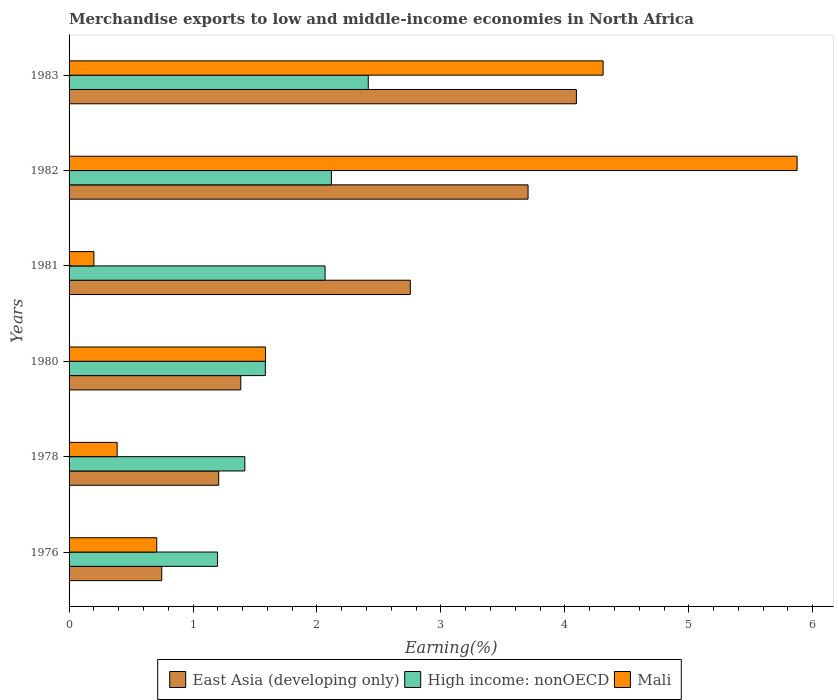Are the number of bars per tick equal to the number of legend labels?
Keep it short and to the point. Yes. How many bars are there on the 1st tick from the bottom?
Your answer should be very brief. 3. What is the percentage of amount earned from merchandise exports in East Asia (developing only) in 1980?
Give a very brief answer. 1.39. Across all years, what is the maximum percentage of amount earned from merchandise exports in High income: nonOECD?
Offer a very short reply. 2.41. Across all years, what is the minimum percentage of amount earned from merchandise exports in Mali?
Your answer should be very brief. 0.2. In which year was the percentage of amount earned from merchandise exports in East Asia (developing only) minimum?
Your answer should be compact. 1976. What is the total percentage of amount earned from merchandise exports in Mali in the graph?
Keep it short and to the point. 13.06. What is the difference between the percentage of amount earned from merchandise exports in Mali in 1982 and that in 1983?
Keep it short and to the point. 1.56. What is the difference between the percentage of amount earned from merchandise exports in High income: nonOECD in 1983 and the percentage of amount earned from merchandise exports in East Asia (developing only) in 1976?
Your response must be concise. 1.67. What is the average percentage of amount earned from merchandise exports in East Asia (developing only) per year?
Your answer should be very brief. 2.31. In the year 1983, what is the difference between the percentage of amount earned from merchandise exports in East Asia (developing only) and percentage of amount earned from merchandise exports in High income: nonOECD?
Your answer should be compact. 1.68. What is the ratio of the percentage of amount earned from merchandise exports in Mali in 1978 to that in 1983?
Make the answer very short. 0.09. Is the percentage of amount earned from merchandise exports in East Asia (developing only) in 1980 less than that in 1983?
Your response must be concise. Yes. What is the difference between the highest and the second highest percentage of amount earned from merchandise exports in Mali?
Make the answer very short. 1.56. What is the difference between the highest and the lowest percentage of amount earned from merchandise exports in Mali?
Your response must be concise. 5.67. In how many years, is the percentage of amount earned from merchandise exports in East Asia (developing only) greater than the average percentage of amount earned from merchandise exports in East Asia (developing only) taken over all years?
Keep it short and to the point. 3. What does the 3rd bar from the top in 1978 represents?
Offer a terse response. East Asia (developing only). What does the 1st bar from the bottom in 1978 represents?
Ensure brevity in your answer.  East Asia (developing only). How many bars are there?
Give a very brief answer. 18. Are all the bars in the graph horizontal?
Keep it short and to the point. Yes. Are the values on the major ticks of X-axis written in scientific E-notation?
Ensure brevity in your answer.  No. Does the graph contain grids?
Provide a succinct answer. No. Where does the legend appear in the graph?
Offer a very short reply. Bottom center. How many legend labels are there?
Keep it short and to the point. 3. How are the legend labels stacked?
Provide a short and direct response. Horizontal. What is the title of the graph?
Your answer should be very brief. Merchandise exports to low and middle-income economies in North Africa. What is the label or title of the X-axis?
Offer a very short reply. Earning(%). What is the Earning(%) in East Asia (developing only) in 1976?
Ensure brevity in your answer.  0.75. What is the Earning(%) of High income: nonOECD in 1976?
Offer a very short reply. 1.2. What is the Earning(%) in Mali in 1976?
Make the answer very short. 0.71. What is the Earning(%) of East Asia (developing only) in 1978?
Make the answer very short. 1.21. What is the Earning(%) of High income: nonOECD in 1978?
Provide a short and direct response. 1.42. What is the Earning(%) of Mali in 1978?
Provide a short and direct response. 0.39. What is the Earning(%) in East Asia (developing only) in 1980?
Give a very brief answer. 1.39. What is the Earning(%) in High income: nonOECD in 1980?
Your answer should be compact. 1.58. What is the Earning(%) in Mali in 1980?
Provide a short and direct response. 1.59. What is the Earning(%) in East Asia (developing only) in 1981?
Your answer should be compact. 2.75. What is the Earning(%) in High income: nonOECD in 1981?
Your response must be concise. 2.07. What is the Earning(%) in Mali in 1981?
Offer a terse response. 0.2. What is the Earning(%) of East Asia (developing only) in 1982?
Give a very brief answer. 3.7. What is the Earning(%) in High income: nonOECD in 1982?
Provide a short and direct response. 2.12. What is the Earning(%) in Mali in 1982?
Offer a terse response. 5.87. What is the Earning(%) in East Asia (developing only) in 1983?
Provide a short and direct response. 4.09. What is the Earning(%) of High income: nonOECD in 1983?
Give a very brief answer. 2.41. What is the Earning(%) in Mali in 1983?
Offer a very short reply. 4.31. Across all years, what is the maximum Earning(%) in East Asia (developing only)?
Your answer should be very brief. 4.09. Across all years, what is the maximum Earning(%) of High income: nonOECD?
Your answer should be compact. 2.41. Across all years, what is the maximum Earning(%) of Mali?
Give a very brief answer. 5.87. Across all years, what is the minimum Earning(%) in East Asia (developing only)?
Offer a very short reply. 0.75. Across all years, what is the minimum Earning(%) in High income: nonOECD?
Offer a terse response. 1.2. Across all years, what is the minimum Earning(%) in Mali?
Keep it short and to the point. 0.2. What is the total Earning(%) in East Asia (developing only) in the graph?
Your answer should be very brief. 13.89. What is the total Earning(%) of High income: nonOECD in the graph?
Offer a terse response. 10.79. What is the total Earning(%) of Mali in the graph?
Keep it short and to the point. 13.06. What is the difference between the Earning(%) in East Asia (developing only) in 1976 and that in 1978?
Ensure brevity in your answer.  -0.46. What is the difference between the Earning(%) in High income: nonOECD in 1976 and that in 1978?
Ensure brevity in your answer.  -0.22. What is the difference between the Earning(%) in Mali in 1976 and that in 1978?
Provide a succinct answer. 0.32. What is the difference between the Earning(%) in East Asia (developing only) in 1976 and that in 1980?
Offer a terse response. -0.64. What is the difference between the Earning(%) of High income: nonOECD in 1976 and that in 1980?
Your answer should be compact. -0.39. What is the difference between the Earning(%) in Mali in 1976 and that in 1980?
Ensure brevity in your answer.  -0.88. What is the difference between the Earning(%) in East Asia (developing only) in 1976 and that in 1981?
Keep it short and to the point. -2.01. What is the difference between the Earning(%) of High income: nonOECD in 1976 and that in 1981?
Your response must be concise. -0.87. What is the difference between the Earning(%) of Mali in 1976 and that in 1981?
Provide a succinct answer. 0.51. What is the difference between the Earning(%) in East Asia (developing only) in 1976 and that in 1982?
Give a very brief answer. -2.96. What is the difference between the Earning(%) in High income: nonOECD in 1976 and that in 1982?
Offer a very short reply. -0.92. What is the difference between the Earning(%) of Mali in 1976 and that in 1982?
Your answer should be compact. -5.17. What is the difference between the Earning(%) of East Asia (developing only) in 1976 and that in 1983?
Give a very brief answer. -3.35. What is the difference between the Earning(%) in High income: nonOECD in 1976 and that in 1983?
Provide a short and direct response. -1.22. What is the difference between the Earning(%) in Mali in 1976 and that in 1983?
Offer a terse response. -3.6. What is the difference between the Earning(%) of East Asia (developing only) in 1978 and that in 1980?
Make the answer very short. -0.18. What is the difference between the Earning(%) in High income: nonOECD in 1978 and that in 1980?
Ensure brevity in your answer.  -0.17. What is the difference between the Earning(%) of Mali in 1978 and that in 1980?
Ensure brevity in your answer.  -1.2. What is the difference between the Earning(%) of East Asia (developing only) in 1978 and that in 1981?
Your answer should be compact. -1.55. What is the difference between the Earning(%) in High income: nonOECD in 1978 and that in 1981?
Make the answer very short. -0.65. What is the difference between the Earning(%) in Mali in 1978 and that in 1981?
Make the answer very short. 0.19. What is the difference between the Earning(%) of East Asia (developing only) in 1978 and that in 1982?
Keep it short and to the point. -2.5. What is the difference between the Earning(%) in High income: nonOECD in 1978 and that in 1982?
Your response must be concise. -0.7. What is the difference between the Earning(%) of Mali in 1978 and that in 1982?
Your answer should be very brief. -5.49. What is the difference between the Earning(%) in East Asia (developing only) in 1978 and that in 1983?
Give a very brief answer. -2.89. What is the difference between the Earning(%) of High income: nonOECD in 1978 and that in 1983?
Keep it short and to the point. -1. What is the difference between the Earning(%) in Mali in 1978 and that in 1983?
Make the answer very short. -3.92. What is the difference between the Earning(%) of East Asia (developing only) in 1980 and that in 1981?
Your response must be concise. -1.37. What is the difference between the Earning(%) of High income: nonOECD in 1980 and that in 1981?
Your response must be concise. -0.48. What is the difference between the Earning(%) in Mali in 1980 and that in 1981?
Give a very brief answer. 1.38. What is the difference between the Earning(%) in East Asia (developing only) in 1980 and that in 1982?
Keep it short and to the point. -2.32. What is the difference between the Earning(%) of High income: nonOECD in 1980 and that in 1982?
Your answer should be very brief. -0.53. What is the difference between the Earning(%) of Mali in 1980 and that in 1982?
Provide a short and direct response. -4.29. What is the difference between the Earning(%) in East Asia (developing only) in 1980 and that in 1983?
Your answer should be very brief. -2.71. What is the difference between the Earning(%) in High income: nonOECD in 1980 and that in 1983?
Keep it short and to the point. -0.83. What is the difference between the Earning(%) in Mali in 1980 and that in 1983?
Provide a succinct answer. -2.72. What is the difference between the Earning(%) of East Asia (developing only) in 1981 and that in 1982?
Provide a short and direct response. -0.95. What is the difference between the Earning(%) of High income: nonOECD in 1981 and that in 1982?
Provide a succinct answer. -0.05. What is the difference between the Earning(%) of Mali in 1981 and that in 1982?
Your response must be concise. -5.67. What is the difference between the Earning(%) in East Asia (developing only) in 1981 and that in 1983?
Your answer should be very brief. -1.34. What is the difference between the Earning(%) of High income: nonOECD in 1981 and that in 1983?
Offer a terse response. -0.35. What is the difference between the Earning(%) of Mali in 1981 and that in 1983?
Your response must be concise. -4.11. What is the difference between the Earning(%) of East Asia (developing only) in 1982 and that in 1983?
Your response must be concise. -0.39. What is the difference between the Earning(%) of High income: nonOECD in 1982 and that in 1983?
Your answer should be compact. -0.3. What is the difference between the Earning(%) of Mali in 1982 and that in 1983?
Your answer should be very brief. 1.56. What is the difference between the Earning(%) in East Asia (developing only) in 1976 and the Earning(%) in High income: nonOECD in 1978?
Ensure brevity in your answer.  -0.67. What is the difference between the Earning(%) in East Asia (developing only) in 1976 and the Earning(%) in Mali in 1978?
Your answer should be compact. 0.36. What is the difference between the Earning(%) in High income: nonOECD in 1976 and the Earning(%) in Mali in 1978?
Give a very brief answer. 0.81. What is the difference between the Earning(%) in East Asia (developing only) in 1976 and the Earning(%) in High income: nonOECD in 1980?
Your answer should be very brief. -0.84. What is the difference between the Earning(%) of East Asia (developing only) in 1976 and the Earning(%) of Mali in 1980?
Your answer should be compact. -0.84. What is the difference between the Earning(%) of High income: nonOECD in 1976 and the Earning(%) of Mali in 1980?
Your answer should be very brief. -0.39. What is the difference between the Earning(%) in East Asia (developing only) in 1976 and the Earning(%) in High income: nonOECD in 1981?
Offer a very short reply. -1.32. What is the difference between the Earning(%) of East Asia (developing only) in 1976 and the Earning(%) of Mali in 1981?
Your response must be concise. 0.55. What is the difference between the Earning(%) in High income: nonOECD in 1976 and the Earning(%) in Mali in 1981?
Make the answer very short. 1. What is the difference between the Earning(%) of East Asia (developing only) in 1976 and the Earning(%) of High income: nonOECD in 1982?
Provide a succinct answer. -1.37. What is the difference between the Earning(%) in East Asia (developing only) in 1976 and the Earning(%) in Mali in 1982?
Ensure brevity in your answer.  -5.13. What is the difference between the Earning(%) in High income: nonOECD in 1976 and the Earning(%) in Mali in 1982?
Ensure brevity in your answer.  -4.68. What is the difference between the Earning(%) in East Asia (developing only) in 1976 and the Earning(%) in High income: nonOECD in 1983?
Keep it short and to the point. -1.67. What is the difference between the Earning(%) in East Asia (developing only) in 1976 and the Earning(%) in Mali in 1983?
Ensure brevity in your answer.  -3.56. What is the difference between the Earning(%) of High income: nonOECD in 1976 and the Earning(%) of Mali in 1983?
Provide a succinct answer. -3.11. What is the difference between the Earning(%) in East Asia (developing only) in 1978 and the Earning(%) in High income: nonOECD in 1980?
Ensure brevity in your answer.  -0.38. What is the difference between the Earning(%) of East Asia (developing only) in 1978 and the Earning(%) of Mali in 1980?
Offer a very short reply. -0.38. What is the difference between the Earning(%) of High income: nonOECD in 1978 and the Earning(%) of Mali in 1980?
Offer a very short reply. -0.17. What is the difference between the Earning(%) of East Asia (developing only) in 1978 and the Earning(%) of High income: nonOECD in 1981?
Your response must be concise. -0.86. What is the difference between the Earning(%) in East Asia (developing only) in 1978 and the Earning(%) in Mali in 1981?
Your response must be concise. 1.01. What is the difference between the Earning(%) of High income: nonOECD in 1978 and the Earning(%) of Mali in 1981?
Keep it short and to the point. 1.22. What is the difference between the Earning(%) of East Asia (developing only) in 1978 and the Earning(%) of High income: nonOECD in 1982?
Your answer should be compact. -0.91. What is the difference between the Earning(%) in East Asia (developing only) in 1978 and the Earning(%) in Mali in 1982?
Provide a succinct answer. -4.67. What is the difference between the Earning(%) of High income: nonOECD in 1978 and the Earning(%) of Mali in 1982?
Offer a terse response. -4.46. What is the difference between the Earning(%) of East Asia (developing only) in 1978 and the Earning(%) of High income: nonOECD in 1983?
Offer a terse response. -1.21. What is the difference between the Earning(%) of East Asia (developing only) in 1978 and the Earning(%) of Mali in 1983?
Ensure brevity in your answer.  -3.1. What is the difference between the Earning(%) in High income: nonOECD in 1978 and the Earning(%) in Mali in 1983?
Offer a very short reply. -2.89. What is the difference between the Earning(%) in East Asia (developing only) in 1980 and the Earning(%) in High income: nonOECD in 1981?
Offer a very short reply. -0.68. What is the difference between the Earning(%) in East Asia (developing only) in 1980 and the Earning(%) in Mali in 1981?
Offer a very short reply. 1.18. What is the difference between the Earning(%) of High income: nonOECD in 1980 and the Earning(%) of Mali in 1981?
Make the answer very short. 1.38. What is the difference between the Earning(%) of East Asia (developing only) in 1980 and the Earning(%) of High income: nonOECD in 1982?
Offer a terse response. -0.73. What is the difference between the Earning(%) of East Asia (developing only) in 1980 and the Earning(%) of Mali in 1982?
Ensure brevity in your answer.  -4.49. What is the difference between the Earning(%) of High income: nonOECD in 1980 and the Earning(%) of Mali in 1982?
Keep it short and to the point. -4.29. What is the difference between the Earning(%) in East Asia (developing only) in 1980 and the Earning(%) in High income: nonOECD in 1983?
Give a very brief answer. -1.03. What is the difference between the Earning(%) of East Asia (developing only) in 1980 and the Earning(%) of Mali in 1983?
Offer a very short reply. -2.92. What is the difference between the Earning(%) in High income: nonOECD in 1980 and the Earning(%) in Mali in 1983?
Offer a terse response. -2.73. What is the difference between the Earning(%) of East Asia (developing only) in 1981 and the Earning(%) of High income: nonOECD in 1982?
Make the answer very short. 0.64. What is the difference between the Earning(%) in East Asia (developing only) in 1981 and the Earning(%) in Mali in 1982?
Give a very brief answer. -3.12. What is the difference between the Earning(%) in High income: nonOECD in 1981 and the Earning(%) in Mali in 1982?
Provide a short and direct response. -3.81. What is the difference between the Earning(%) in East Asia (developing only) in 1981 and the Earning(%) in High income: nonOECD in 1983?
Offer a terse response. 0.34. What is the difference between the Earning(%) in East Asia (developing only) in 1981 and the Earning(%) in Mali in 1983?
Your answer should be very brief. -1.56. What is the difference between the Earning(%) in High income: nonOECD in 1981 and the Earning(%) in Mali in 1983?
Your answer should be compact. -2.24. What is the difference between the Earning(%) in East Asia (developing only) in 1982 and the Earning(%) in High income: nonOECD in 1983?
Provide a succinct answer. 1.29. What is the difference between the Earning(%) in East Asia (developing only) in 1982 and the Earning(%) in Mali in 1983?
Ensure brevity in your answer.  -0.61. What is the difference between the Earning(%) of High income: nonOECD in 1982 and the Earning(%) of Mali in 1983?
Provide a short and direct response. -2.19. What is the average Earning(%) in East Asia (developing only) per year?
Your response must be concise. 2.31. What is the average Earning(%) of High income: nonOECD per year?
Provide a short and direct response. 1.8. What is the average Earning(%) of Mali per year?
Your answer should be very brief. 2.18. In the year 1976, what is the difference between the Earning(%) in East Asia (developing only) and Earning(%) in High income: nonOECD?
Your answer should be very brief. -0.45. In the year 1976, what is the difference between the Earning(%) in East Asia (developing only) and Earning(%) in Mali?
Your response must be concise. 0.04. In the year 1976, what is the difference between the Earning(%) in High income: nonOECD and Earning(%) in Mali?
Your response must be concise. 0.49. In the year 1978, what is the difference between the Earning(%) in East Asia (developing only) and Earning(%) in High income: nonOECD?
Offer a very short reply. -0.21. In the year 1978, what is the difference between the Earning(%) of East Asia (developing only) and Earning(%) of Mali?
Make the answer very short. 0.82. In the year 1978, what is the difference between the Earning(%) in High income: nonOECD and Earning(%) in Mali?
Ensure brevity in your answer.  1.03. In the year 1980, what is the difference between the Earning(%) of East Asia (developing only) and Earning(%) of High income: nonOECD?
Give a very brief answer. -0.2. In the year 1980, what is the difference between the Earning(%) of East Asia (developing only) and Earning(%) of Mali?
Your response must be concise. -0.2. In the year 1980, what is the difference between the Earning(%) of High income: nonOECD and Earning(%) of Mali?
Give a very brief answer. -0. In the year 1981, what is the difference between the Earning(%) of East Asia (developing only) and Earning(%) of High income: nonOECD?
Provide a short and direct response. 0.69. In the year 1981, what is the difference between the Earning(%) of East Asia (developing only) and Earning(%) of Mali?
Offer a very short reply. 2.55. In the year 1981, what is the difference between the Earning(%) in High income: nonOECD and Earning(%) in Mali?
Your answer should be compact. 1.86. In the year 1982, what is the difference between the Earning(%) of East Asia (developing only) and Earning(%) of High income: nonOECD?
Make the answer very short. 1.59. In the year 1982, what is the difference between the Earning(%) in East Asia (developing only) and Earning(%) in Mali?
Your answer should be very brief. -2.17. In the year 1982, what is the difference between the Earning(%) in High income: nonOECD and Earning(%) in Mali?
Offer a terse response. -3.76. In the year 1983, what is the difference between the Earning(%) in East Asia (developing only) and Earning(%) in High income: nonOECD?
Make the answer very short. 1.68. In the year 1983, what is the difference between the Earning(%) in East Asia (developing only) and Earning(%) in Mali?
Provide a succinct answer. -0.22. In the year 1983, what is the difference between the Earning(%) of High income: nonOECD and Earning(%) of Mali?
Provide a succinct answer. -1.89. What is the ratio of the Earning(%) in East Asia (developing only) in 1976 to that in 1978?
Your answer should be very brief. 0.62. What is the ratio of the Earning(%) in High income: nonOECD in 1976 to that in 1978?
Offer a terse response. 0.84. What is the ratio of the Earning(%) in Mali in 1976 to that in 1978?
Make the answer very short. 1.82. What is the ratio of the Earning(%) of East Asia (developing only) in 1976 to that in 1980?
Your answer should be compact. 0.54. What is the ratio of the Earning(%) of High income: nonOECD in 1976 to that in 1980?
Ensure brevity in your answer.  0.76. What is the ratio of the Earning(%) in Mali in 1976 to that in 1980?
Offer a terse response. 0.45. What is the ratio of the Earning(%) in East Asia (developing only) in 1976 to that in 1981?
Make the answer very short. 0.27. What is the ratio of the Earning(%) in High income: nonOECD in 1976 to that in 1981?
Your answer should be very brief. 0.58. What is the ratio of the Earning(%) in Mali in 1976 to that in 1981?
Provide a short and direct response. 3.53. What is the ratio of the Earning(%) in East Asia (developing only) in 1976 to that in 1982?
Ensure brevity in your answer.  0.2. What is the ratio of the Earning(%) of High income: nonOECD in 1976 to that in 1982?
Ensure brevity in your answer.  0.57. What is the ratio of the Earning(%) in Mali in 1976 to that in 1982?
Your answer should be compact. 0.12. What is the ratio of the Earning(%) in East Asia (developing only) in 1976 to that in 1983?
Your answer should be very brief. 0.18. What is the ratio of the Earning(%) of High income: nonOECD in 1976 to that in 1983?
Keep it short and to the point. 0.5. What is the ratio of the Earning(%) of Mali in 1976 to that in 1983?
Offer a very short reply. 0.16. What is the ratio of the Earning(%) in East Asia (developing only) in 1978 to that in 1980?
Make the answer very short. 0.87. What is the ratio of the Earning(%) of High income: nonOECD in 1978 to that in 1980?
Your answer should be very brief. 0.9. What is the ratio of the Earning(%) of Mali in 1978 to that in 1980?
Your answer should be compact. 0.24. What is the ratio of the Earning(%) in East Asia (developing only) in 1978 to that in 1981?
Your answer should be compact. 0.44. What is the ratio of the Earning(%) of High income: nonOECD in 1978 to that in 1981?
Give a very brief answer. 0.69. What is the ratio of the Earning(%) of Mali in 1978 to that in 1981?
Your answer should be very brief. 1.93. What is the ratio of the Earning(%) of East Asia (developing only) in 1978 to that in 1982?
Ensure brevity in your answer.  0.33. What is the ratio of the Earning(%) of High income: nonOECD in 1978 to that in 1982?
Provide a short and direct response. 0.67. What is the ratio of the Earning(%) of Mali in 1978 to that in 1982?
Provide a succinct answer. 0.07. What is the ratio of the Earning(%) of East Asia (developing only) in 1978 to that in 1983?
Offer a terse response. 0.29. What is the ratio of the Earning(%) of High income: nonOECD in 1978 to that in 1983?
Make the answer very short. 0.59. What is the ratio of the Earning(%) of Mali in 1978 to that in 1983?
Provide a succinct answer. 0.09. What is the ratio of the Earning(%) in East Asia (developing only) in 1980 to that in 1981?
Keep it short and to the point. 0.5. What is the ratio of the Earning(%) of High income: nonOECD in 1980 to that in 1981?
Provide a succinct answer. 0.77. What is the ratio of the Earning(%) in Mali in 1980 to that in 1981?
Offer a terse response. 7.91. What is the ratio of the Earning(%) in East Asia (developing only) in 1980 to that in 1982?
Provide a short and direct response. 0.37. What is the ratio of the Earning(%) in High income: nonOECD in 1980 to that in 1982?
Give a very brief answer. 0.75. What is the ratio of the Earning(%) in Mali in 1980 to that in 1982?
Provide a short and direct response. 0.27. What is the ratio of the Earning(%) in East Asia (developing only) in 1980 to that in 1983?
Make the answer very short. 0.34. What is the ratio of the Earning(%) of High income: nonOECD in 1980 to that in 1983?
Keep it short and to the point. 0.66. What is the ratio of the Earning(%) in Mali in 1980 to that in 1983?
Offer a terse response. 0.37. What is the ratio of the Earning(%) of East Asia (developing only) in 1981 to that in 1982?
Offer a terse response. 0.74. What is the ratio of the Earning(%) of High income: nonOECD in 1981 to that in 1982?
Your answer should be very brief. 0.98. What is the ratio of the Earning(%) in Mali in 1981 to that in 1982?
Your answer should be compact. 0.03. What is the ratio of the Earning(%) in East Asia (developing only) in 1981 to that in 1983?
Offer a terse response. 0.67. What is the ratio of the Earning(%) of High income: nonOECD in 1981 to that in 1983?
Offer a very short reply. 0.86. What is the ratio of the Earning(%) of Mali in 1981 to that in 1983?
Give a very brief answer. 0.05. What is the ratio of the Earning(%) of East Asia (developing only) in 1982 to that in 1983?
Offer a terse response. 0.9. What is the ratio of the Earning(%) in High income: nonOECD in 1982 to that in 1983?
Your answer should be compact. 0.88. What is the ratio of the Earning(%) of Mali in 1982 to that in 1983?
Give a very brief answer. 1.36. What is the difference between the highest and the second highest Earning(%) in East Asia (developing only)?
Your answer should be very brief. 0.39. What is the difference between the highest and the second highest Earning(%) in High income: nonOECD?
Ensure brevity in your answer.  0.3. What is the difference between the highest and the second highest Earning(%) in Mali?
Your answer should be very brief. 1.56. What is the difference between the highest and the lowest Earning(%) of East Asia (developing only)?
Your answer should be very brief. 3.35. What is the difference between the highest and the lowest Earning(%) of High income: nonOECD?
Make the answer very short. 1.22. What is the difference between the highest and the lowest Earning(%) in Mali?
Make the answer very short. 5.67. 